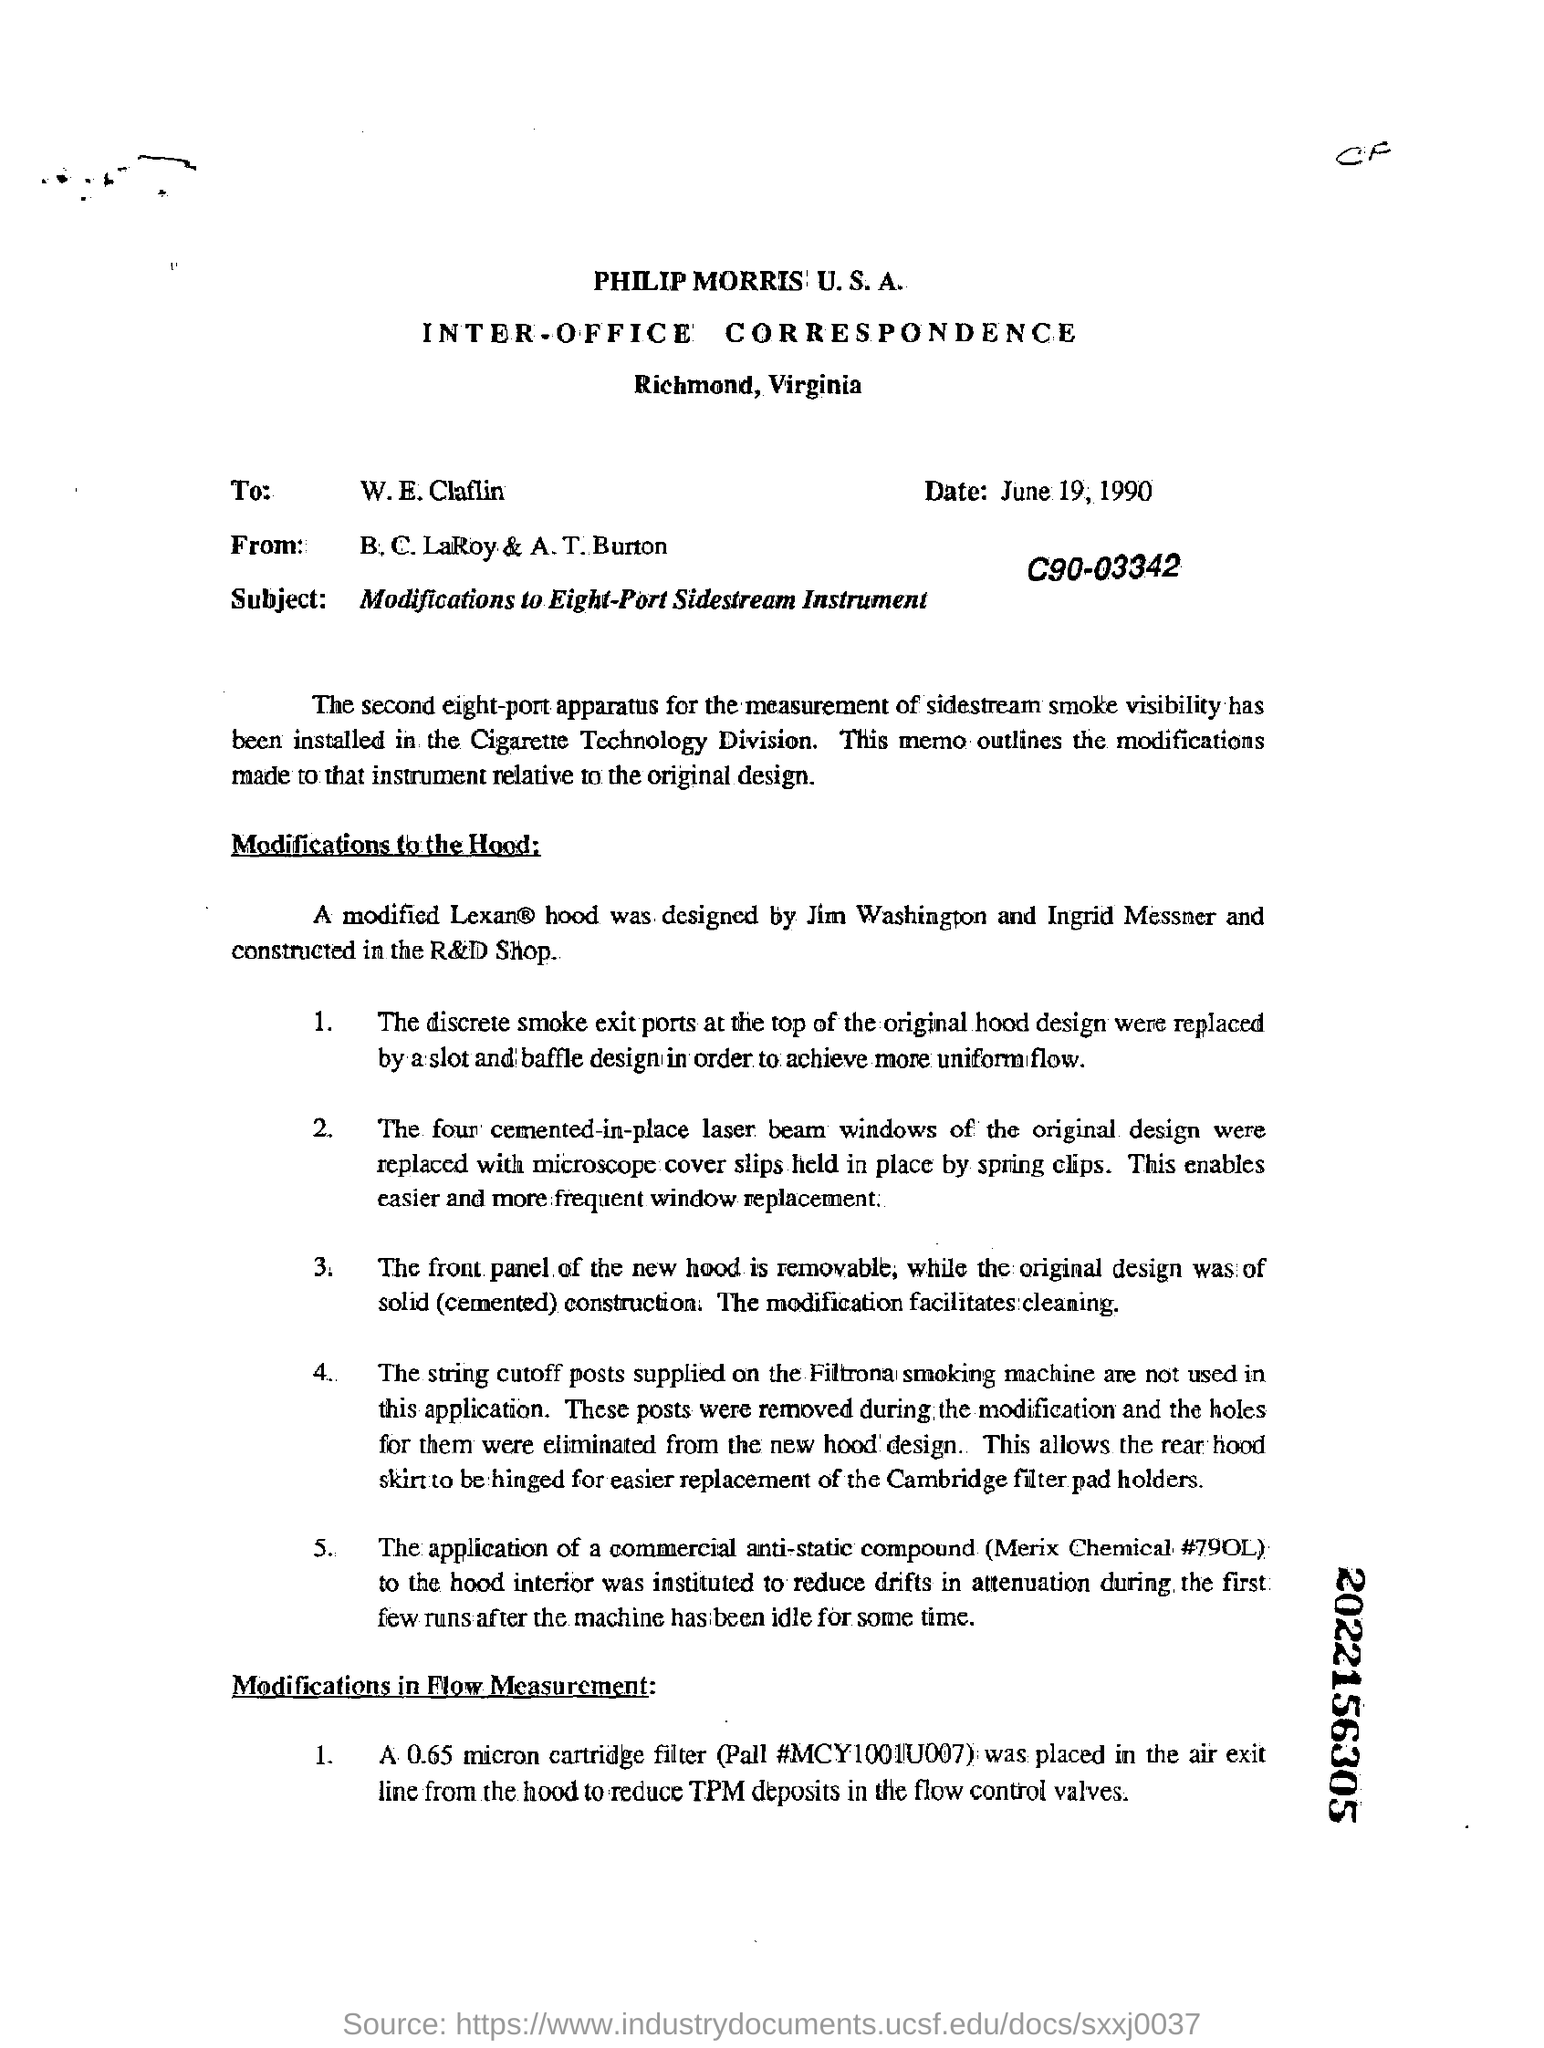To whom is this letter addressed?
Your response must be concise. W.E.Claflin. What is the date mentioned?
Your answer should be very brief. June 19, 1990. What is the subject of the document?
Give a very brief answer. Modifications to Eight-Port Sidestream Instrument. What is the date mentioned in the document ?
Provide a short and direct response. June 19, 1990. 